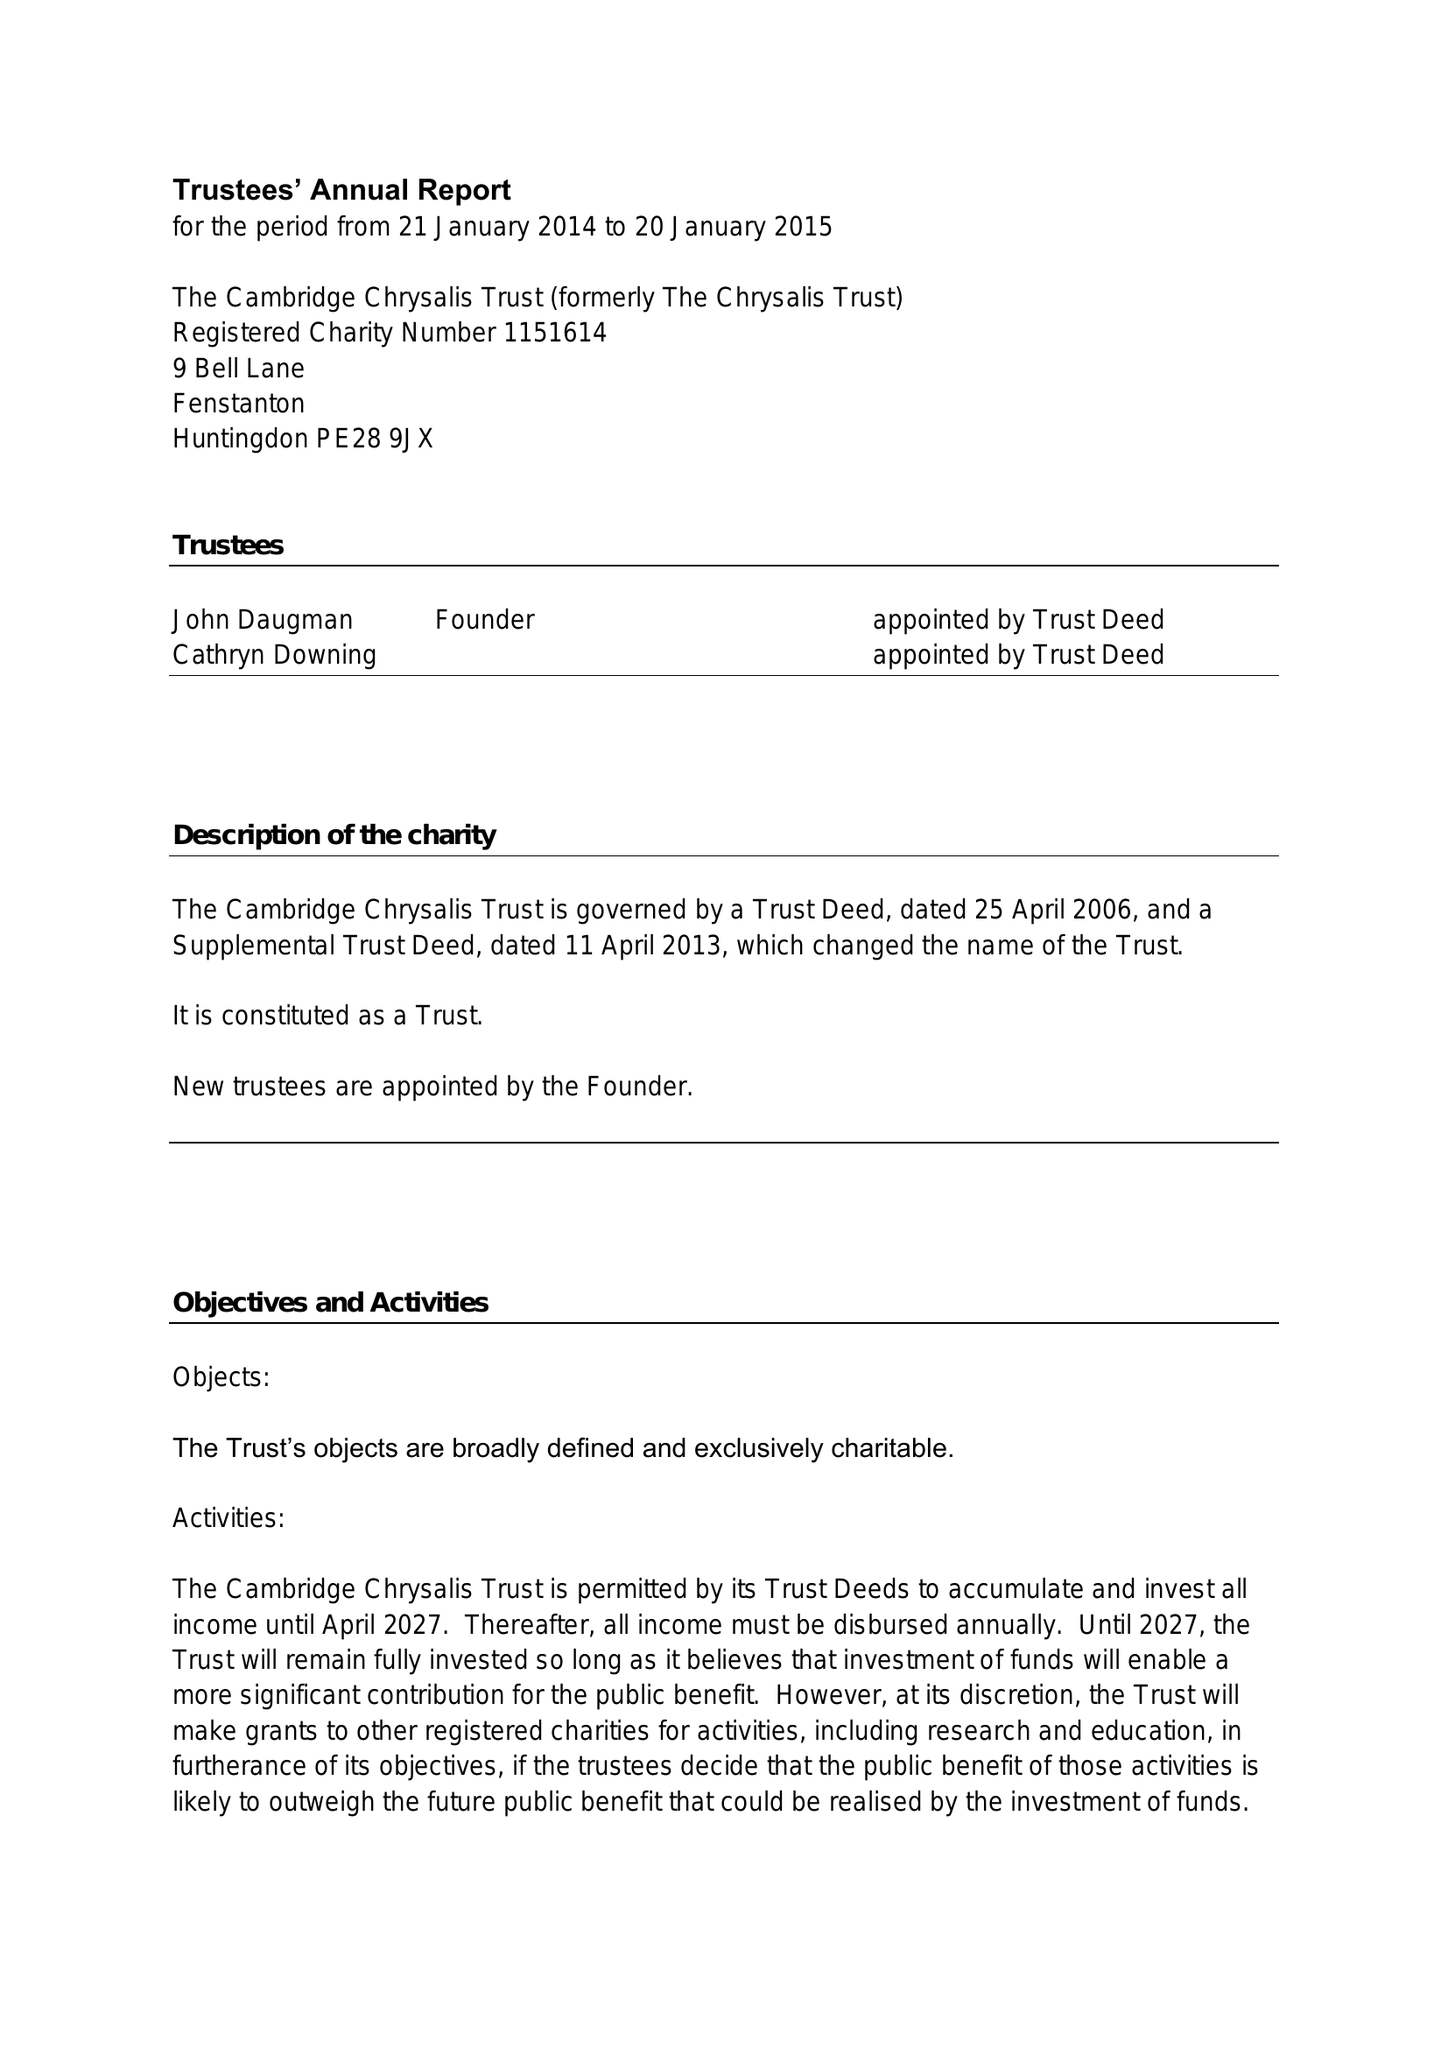What is the value for the charity_name?
Answer the question using a single word or phrase. The Cambridge Chrysalis Trust 